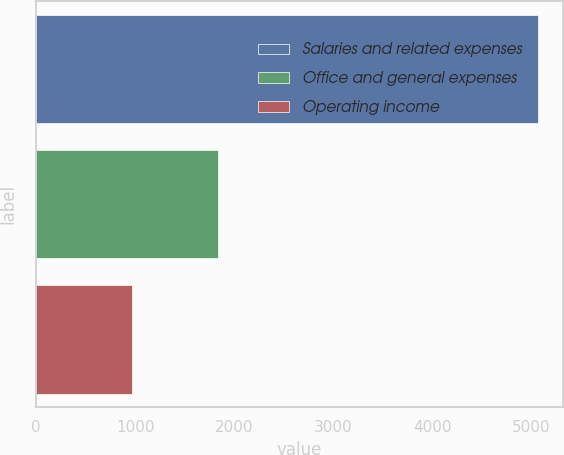Convert chart to OTSL. <chart><loc_0><loc_0><loc_500><loc_500><bar_chart><fcel>Salaries and related expenses<fcel>Office and general expenses<fcel>Operating income<nl><fcel>5068.1<fcel>1840.7<fcel>973.6<nl></chart> 